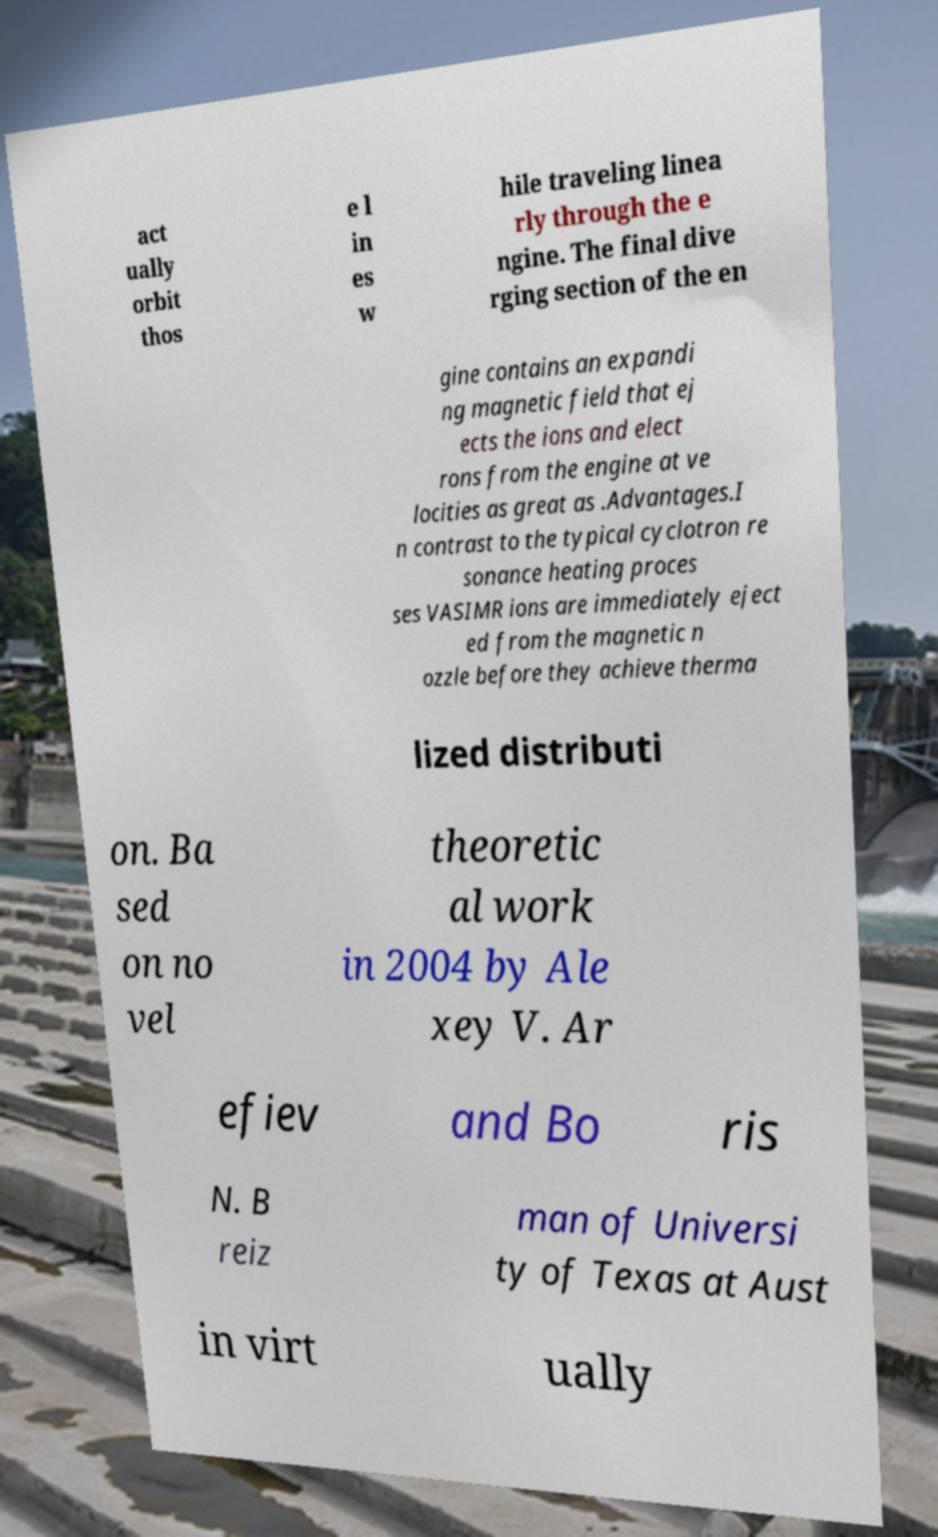I need the written content from this picture converted into text. Can you do that? act ually orbit thos e l in es w hile traveling linea rly through the e ngine. The final dive rging section of the en gine contains an expandi ng magnetic field that ej ects the ions and elect rons from the engine at ve locities as great as .Advantages.I n contrast to the typical cyclotron re sonance heating proces ses VASIMR ions are immediately eject ed from the magnetic n ozzle before they achieve therma lized distributi on. Ba sed on no vel theoretic al work in 2004 by Ale xey V. Ar efiev and Bo ris N. B reiz man of Universi ty of Texas at Aust in virt ually 